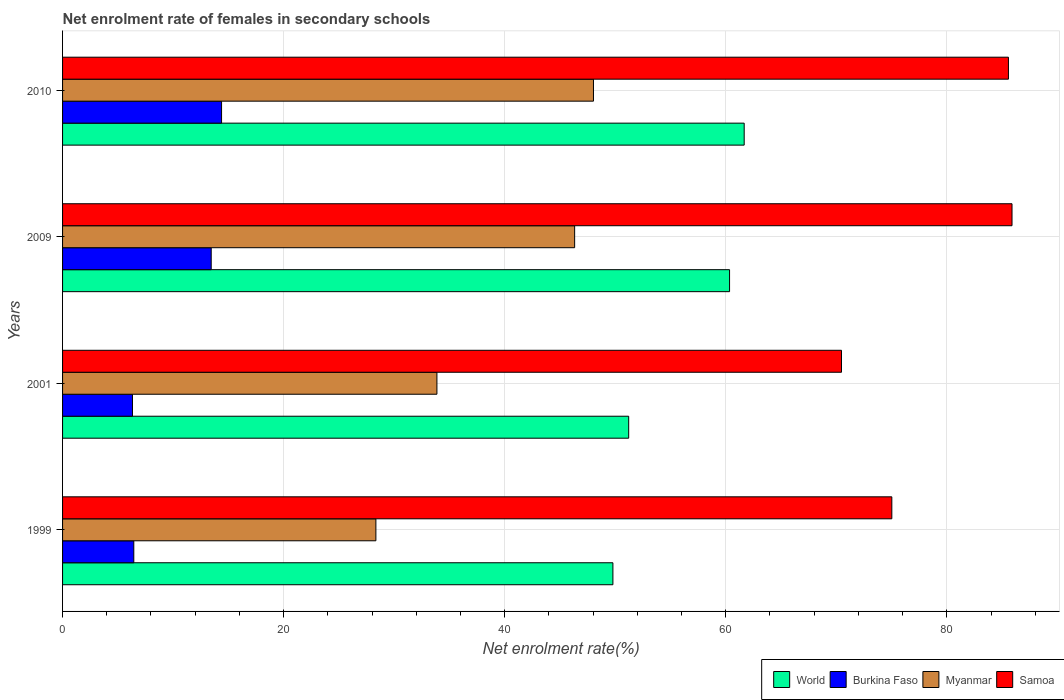Are the number of bars on each tick of the Y-axis equal?
Your response must be concise. Yes. How many bars are there on the 3rd tick from the top?
Your answer should be very brief. 4. How many bars are there on the 4th tick from the bottom?
Your answer should be compact. 4. What is the label of the 1st group of bars from the top?
Keep it short and to the point. 2010. What is the net enrolment rate of females in secondary schools in Myanmar in 2009?
Offer a terse response. 46.33. Across all years, what is the maximum net enrolment rate of females in secondary schools in World?
Give a very brief answer. 61.67. Across all years, what is the minimum net enrolment rate of females in secondary schools in Samoa?
Give a very brief answer. 70.47. In which year was the net enrolment rate of females in secondary schools in Samoa maximum?
Your response must be concise. 2009. What is the total net enrolment rate of females in secondary schools in Myanmar in the graph?
Provide a succinct answer. 156.58. What is the difference between the net enrolment rate of females in secondary schools in Burkina Faso in 2001 and that in 2009?
Provide a succinct answer. -7.12. What is the difference between the net enrolment rate of females in secondary schools in Burkina Faso in 2001 and the net enrolment rate of females in secondary schools in World in 1999?
Ensure brevity in your answer.  -43.47. What is the average net enrolment rate of females in secondary schools in Burkina Faso per year?
Provide a succinct answer. 10.15. In the year 2001, what is the difference between the net enrolment rate of females in secondary schools in World and net enrolment rate of females in secondary schools in Burkina Faso?
Keep it short and to the point. 44.89. In how many years, is the net enrolment rate of females in secondary schools in Myanmar greater than 24 %?
Provide a succinct answer. 4. What is the ratio of the net enrolment rate of females in secondary schools in Myanmar in 1999 to that in 2001?
Provide a short and direct response. 0.84. Is the net enrolment rate of females in secondary schools in Samoa in 1999 less than that in 2009?
Make the answer very short. Yes. What is the difference between the highest and the second highest net enrolment rate of females in secondary schools in World?
Offer a very short reply. 1.32. What is the difference between the highest and the lowest net enrolment rate of females in secondary schools in Burkina Faso?
Provide a short and direct response. 8.06. In how many years, is the net enrolment rate of females in secondary schools in Burkina Faso greater than the average net enrolment rate of females in secondary schools in Burkina Faso taken over all years?
Offer a terse response. 2. Is the sum of the net enrolment rate of females in secondary schools in Samoa in 2009 and 2010 greater than the maximum net enrolment rate of females in secondary schools in World across all years?
Offer a terse response. Yes. What does the 2nd bar from the top in 1999 represents?
Offer a very short reply. Myanmar. What does the 4th bar from the bottom in 2010 represents?
Provide a short and direct response. Samoa. How many years are there in the graph?
Offer a very short reply. 4. What is the difference between two consecutive major ticks on the X-axis?
Your answer should be compact. 20. Does the graph contain any zero values?
Ensure brevity in your answer.  No. Where does the legend appear in the graph?
Ensure brevity in your answer.  Bottom right. What is the title of the graph?
Your answer should be compact. Net enrolment rate of females in secondary schools. What is the label or title of the X-axis?
Make the answer very short. Net enrolment rate(%). What is the Net enrolment rate(%) in World in 1999?
Your response must be concise. 49.79. What is the Net enrolment rate(%) in Burkina Faso in 1999?
Ensure brevity in your answer.  6.44. What is the Net enrolment rate(%) of Myanmar in 1999?
Ensure brevity in your answer.  28.35. What is the Net enrolment rate(%) of Samoa in 1999?
Ensure brevity in your answer.  75.03. What is the Net enrolment rate(%) of World in 2001?
Make the answer very short. 51.22. What is the Net enrolment rate(%) of Burkina Faso in 2001?
Your answer should be compact. 6.33. What is the Net enrolment rate(%) of Myanmar in 2001?
Make the answer very short. 33.87. What is the Net enrolment rate(%) in Samoa in 2001?
Give a very brief answer. 70.47. What is the Net enrolment rate(%) in World in 2009?
Your response must be concise. 60.35. What is the Net enrolment rate(%) of Burkina Faso in 2009?
Give a very brief answer. 13.45. What is the Net enrolment rate(%) of Myanmar in 2009?
Your response must be concise. 46.33. What is the Net enrolment rate(%) in Samoa in 2009?
Offer a terse response. 85.9. What is the Net enrolment rate(%) of World in 2010?
Your response must be concise. 61.67. What is the Net enrolment rate(%) of Burkina Faso in 2010?
Your response must be concise. 14.39. What is the Net enrolment rate(%) of Myanmar in 2010?
Give a very brief answer. 48.03. What is the Net enrolment rate(%) of Samoa in 2010?
Ensure brevity in your answer.  85.58. Across all years, what is the maximum Net enrolment rate(%) in World?
Provide a short and direct response. 61.67. Across all years, what is the maximum Net enrolment rate(%) in Burkina Faso?
Your answer should be compact. 14.39. Across all years, what is the maximum Net enrolment rate(%) in Myanmar?
Offer a terse response. 48.03. Across all years, what is the maximum Net enrolment rate(%) in Samoa?
Make the answer very short. 85.9. Across all years, what is the minimum Net enrolment rate(%) of World?
Offer a very short reply. 49.79. Across all years, what is the minimum Net enrolment rate(%) in Burkina Faso?
Your answer should be very brief. 6.33. Across all years, what is the minimum Net enrolment rate(%) of Myanmar?
Offer a terse response. 28.35. Across all years, what is the minimum Net enrolment rate(%) in Samoa?
Offer a very short reply. 70.47. What is the total Net enrolment rate(%) of World in the graph?
Your answer should be very brief. 223.03. What is the total Net enrolment rate(%) of Burkina Faso in the graph?
Your response must be concise. 40.6. What is the total Net enrolment rate(%) in Myanmar in the graph?
Provide a succinct answer. 156.58. What is the total Net enrolment rate(%) of Samoa in the graph?
Give a very brief answer. 316.98. What is the difference between the Net enrolment rate(%) in World in 1999 and that in 2001?
Your response must be concise. -1.43. What is the difference between the Net enrolment rate(%) in Burkina Faso in 1999 and that in 2001?
Your answer should be compact. 0.12. What is the difference between the Net enrolment rate(%) in Myanmar in 1999 and that in 2001?
Provide a succinct answer. -5.52. What is the difference between the Net enrolment rate(%) in Samoa in 1999 and that in 2001?
Give a very brief answer. 4.55. What is the difference between the Net enrolment rate(%) of World in 1999 and that in 2009?
Your response must be concise. -10.55. What is the difference between the Net enrolment rate(%) in Burkina Faso in 1999 and that in 2009?
Offer a very short reply. -7. What is the difference between the Net enrolment rate(%) of Myanmar in 1999 and that in 2009?
Offer a terse response. -17.98. What is the difference between the Net enrolment rate(%) of Samoa in 1999 and that in 2009?
Offer a terse response. -10.88. What is the difference between the Net enrolment rate(%) of World in 1999 and that in 2010?
Keep it short and to the point. -11.88. What is the difference between the Net enrolment rate(%) of Burkina Faso in 1999 and that in 2010?
Keep it short and to the point. -7.94. What is the difference between the Net enrolment rate(%) of Myanmar in 1999 and that in 2010?
Keep it short and to the point. -19.69. What is the difference between the Net enrolment rate(%) of Samoa in 1999 and that in 2010?
Ensure brevity in your answer.  -10.55. What is the difference between the Net enrolment rate(%) of World in 2001 and that in 2009?
Your response must be concise. -9.13. What is the difference between the Net enrolment rate(%) of Burkina Faso in 2001 and that in 2009?
Your response must be concise. -7.12. What is the difference between the Net enrolment rate(%) in Myanmar in 2001 and that in 2009?
Your response must be concise. -12.46. What is the difference between the Net enrolment rate(%) in Samoa in 2001 and that in 2009?
Offer a terse response. -15.43. What is the difference between the Net enrolment rate(%) in World in 2001 and that in 2010?
Your response must be concise. -10.45. What is the difference between the Net enrolment rate(%) in Burkina Faso in 2001 and that in 2010?
Make the answer very short. -8.06. What is the difference between the Net enrolment rate(%) in Myanmar in 2001 and that in 2010?
Offer a very short reply. -14.16. What is the difference between the Net enrolment rate(%) in Samoa in 2001 and that in 2010?
Make the answer very short. -15.1. What is the difference between the Net enrolment rate(%) in World in 2009 and that in 2010?
Your answer should be compact. -1.32. What is the difference between the Net enrolment rate(%) of Burkina Faso in 2009 and that in 2010?
Offer a very short reply. -0.94. What is the difference between the Net enrolment rate(%) of Myanmar in 2009 and that in 2010?
Provide a succinct answer. -1.7. What is the difference between the Net enrolment rate(%) of Samoa in 2009 and that in 2010?
Provide a short and direct response. 0.32. What is the difference between the Net enrolment rate(%) in World in 1999 and the Net enrolment rate(%) in Burkina Faso in 2001?
Your answer should be very brief. 43.47. What is the difference between the Net enrolment rate(%) in World in 1999 and the Net enrolment rate(%) in Myanmar in 2001?
Ensure brevity in your answer.  15.92. What is the difference between the Net enrolment rate(%) in World in 1999 and the Net enrolment rate(%) in Samoa in 2001?
Keep it short and to the point. -20.68. What is the difference between the Net enrolment rate(%) in Burkina Faso in 1999 and the Net enrolment rate(%) in Myanmar in 2001?
Offer a very short reply. -27.43. What is the difference between the Net enrolment rate(%) in Burkina Faso in 1999 and the Net enrolment rate(%) in Samoa in 2001?
Give a very brief answer. -64.03. What is the difference between the Net enrolment rate(%) in Myanmar in 1999 and the Net enrolment rate(%) in Samoa in 2001?
Keep it short and to the point. -42.13. What is the difference between the Net enrolment rate(%) in World in 1999 and the Net enrolment rate(%) in Burkina Faso in 2009?
Provide a short and direct response. 36.34. What is the difference between the Net enrolment rate(%) in World in 1999 and the Net enrolment rate(%) in Myanmar in 2009?
Make the answer very short. 3.46. What is the difference between the Net enrolment rate(%) of World in 1999 and the Net enrolment rate(%) of Samoa in 2009?
Give a very brief answer. -36.11. What is the difference between the Net enrolment rate(%) in Burkina Faso in 1999 and the Net enrolment rate(%) in Myanmar in 2009?
Your response must be concise. -39.88. What is the difference between the Net enrolment rate(%) of Burkina Faso in 1999 and the Net enrolment rate(%) of Samoa in 2009?
Ensure brevity in your answer.  -79.46. What is the difference between the Net enrolment rate(%) in Myanmar in 1999 and the Net enrolment rate(%) in Samoa in 2009?
Your answer should be very brief. -57.55. What is the difference between the Net enrolment rate(%) of World in 1999 and the Net enrolment rate(%) of Burkina Faso in 2010?
Your answer should be compact. 35.41. What is the difference between the Net enrolment rate(%) of World in 1999 and the Net enrolment rate(%) of Myanmar in 2010?
Keep it short and to the point. 1.76. What is the difference between the Net enrolment rate(%) of World in 1999 and the Net enrolment rate(%) of Samoa in 2010?
Offer a very short reply. -35.79. What is the difference between the Net enrolment rate(%) in Burkina Faso in 1999 and the Net enrolment rate(%) in Myanmar in 2010?
Your answer should be very brief. -41.59. What is the difference between the Net enrolment rate(%) of Burkina Faso in 1999 and the Net enrolment rate(%) of Samoa in 2010?
Keep it short and to the point. -79.13. What is the difference between the Net enrolment rate(%) of Myanmar in 1999 and the Net enrolment rate(%) of Samoa in 2010?
Keep it short and to the point. -57.23. What is the difference between the Net enrolment rate(%) in World in 2001 and the Net enrolment rate(%) in Burkina Faso in 2009?
Your answer should be very brief. 37.77. What is the difference between the Net enrolment rate(%) of World in 2001 and the Net enrolment rate(%) of Myanmar in 2009?
Offer a terse response. 4.89. What is the difference between the Net enrolment rate(%) in World in 2001 and the Net enrolment rate(%) in Samoa in 2009?
Your answer should be very brief. -34.68. What is the difference between the Net enrolment rate(%) of Burkina Faso in 2001 and the Net enrolment rate(%) of Myanmar in 2009?
Your response must be concise. -40. What is the difference between the Net enrolment rate(%) of Burkina Faso in 2001 and the Net enrolment rate(%) of Samoa in 2009?
Offer a terse response. -79.58. What is the difference between the Net enrolment rate(%) of Myanmar in 2001 and the Net enrolment rate(%) of Samoa in 2009?
Make the answer very short. -52.03. What is the difference between the Net enrolment rate(%) in World in 2001 and the Net enrolment rate(%) in Burkina Faso in 2010?
Offer a terse response. 36.84. What is the difference between the Net enrolment rate(%) of World in 2001 and the Net enrolment rate(%) of Myanmar in 2010?
Provide a short and direct response. 3.19. What is the difference between the Net enrolment rate(%) of World in 2001 and the Net enrolment rate(%) of Samoa in 2010?
Your answer should be compact. -34.36. What is the difference between the Net enrolment rate(%) in Burkina Faso in 2001 and the Net enrolment rate(%) in Myanmar in 2010?
Keep it short and to the point. -41.71. What is the difference between the Net enrolment rate(%) in Burkina Faso in 2001 and the Net enrolment rate(%) in Samoa in 2010?
Give a very brief answer. -79.25. What is the difference between the Net enrolment rate(%) of Myanmar in 2001 and the Net enrolment rate(%) of Samoa in 2010?
Offer a very short reply. -51.71. What is the difference between the Net enrolment rate(%) of World in 2009 and the Net enrolment rate(%) of Burkina Faso in 2010?
Make the answer very short. 45.96. What is the difference between the Net enrolment rate(%) in World in 2009 and the Net enrolment rate(%) in Myanmar in 2010?
Keep it short and to the point. 12.31. What is the difference between the Net enrolment rate(%) of World in 2009 and the Net enrolment rate(%) of Samoa in 2010?
Provide a short and direct response. -25.23. What is the difference between the Net enrolment rate(%) in Burkina Faso in 2009 and the Net enrolment rate(%) in Myanmar in 2010?
Offer a very short reply. -34.59. What is the difference between the Net enrolment rate(%) of Burkina Faso in 2009 and the Net enrolment rate(%) of Samoa in 2010?
Keep it short and to the point. -72.13. What is the difference between the Net enrolment rate(%) in Myanmar in 2009 and the Net enrolment rate(%) in Samoa in 2010?
Give a very brief answer. -39.25. What is the average Net enrolment rate(%) in World per year?
Give a very brief answer. 55.76. What is the average Net enrolment rate(%) in Burkina Faso per year?
Keep it short and to the point. 10.15. What is the average Net enrolment rate(%) in Myanmar per year?
Provide a succinct answer. 39.15. What is the average Net enrolment rate(%) of Samoa per year?
Your response must be concise. 79.25. In the year 1999, what is the difference between the Net enrolment rate(%) in World and Net enrolment rate(%) in Burkina Faso?
Offer a terse response. 43.35. In the year 1999, what is the difference between the Net enrolment rate(%) of World and Net enrolment rate(%) of Myanmar?
Offer a terse response. 21.44. In the year 1999, what is the difference between the Net enrolment rate(%) of World and Net enrolment rate(%) of Samoa?
Provide a succinct answer. -25.23. In the year 1999, what is the difference between the Net enrolment rate(%) of Burkina Faso and Net enrolment rate(%) of Myanmar?
Make the answer very short. -21.9. In the year 1999, what is the difference between the Net enrolment rate(%) of Burkina Faso and Net enrolment rate(%) of Samoa?
Ensure brevity in your answer.  -68.58. In the year 1999, what is the difference between the Net enrolment rate(%) in Myanmar and Net enrolment rate(%) in Samoa?
Keep it short and to the point. -46.68. In the year 2001, what is the difference between the Net enrolment rate(%) in World and Net enrolment rate(%) in Burkina Faso?
Your answer should be very brief. 44.89. In the year 2001, what is the difference between the Net enrolment rate(%) of World and Net enrolment rate(%) of Myanmar?
Your answer should be very brief. 17.35. In the year 2001, what is the difference between the Net enrolment rate(%) in World and Net enrolment rate(%) in Samoa?
Give a very brief answer. -19.25. In the year 2001, what is the difference between the Net enrolment rate(%) in Burkina Faso and Net enrolment rate(%) in Myanmar?
Offer a very short reply. -27.54. In the year 2001, what is the difference between the Net enrolment rate(%) in Burkina Faso and Net enrolment rate(%) in Samoa?
Keep it short and to the point. -64.15. In the year 2001, what is the difference between the Net enrolment rate(%) of Myanmar and Net enrolment rate(%) of Samoa?
Your response must be concise. -36.6. In the year 2009, what is the difference between the Net enrolment rate(%) of World and Net enrolment rate(%) of Burkina Faso?
Offer a terse response. 46.9. In the year 2009, what is the difference between the Net enrolment rate(%) of World and Net enrolment rate(%) of Myanmar?
Your response must be concise. 14.02. In the year 2009, what is the difference between the Net enrolment rate(%) of World and Net enrolment rate(%) of Samoa?
Provide a succinct answer. -25.55. In the year 2009, what is the difference between the Net enrolment rate(%) of Burkina Faso and Net enrolment rate(%) of Myanmar?
Keep it short and to the point. -32.88. In the year 2009, what is the difference between the Net enrolment rate(%) of Burkina Faso and Net enrolment rate(%) of Samoa?
Give a very brief answer. -72.45. In the year 2009, what is the difference between the Net enrolment rate(%) in Myanmar and Net enrolment rate(%) in Samoa?
Offer a very short reply. -39.57. In the year 2010, what is the difference between the Net enrolment rate(%) in World and Net enrolment rate(%) in Burkina Faso?
Offer a terse response. 47.28. In the year 2010, what is the difference between the Net enrolment rate(%) in World and Net enrolment rate(%) in Myanmar?
Provide a short and direct response. 13.64. In the year 2010, what is the difference between the Net enrolment rate(%) of World and Net enrolment rate(%) of Samoa?
Ensure brevity in your answer.  -23.91. In the year 2010, what is the difference between the Net enrolment rate(%) in Burkina Faso and Net enrolment rate(%) in Myanmar?
Keep it short and to the point. -33.65. In the year 2010, what is the difference between the Net enrolment rate(%) of Burkina Faso and Net enrolment rate(%) of Samoa?
Make the answer very short. -71.19. In the year 2010, what is the difference between the Net enrolment rate(%) in Myanmar and Net enrolment rate(%) in Samoa?
Keep it short and to the point. -37.54. What is the ratio of the Net enrolment rate(%) of World in 1999 to that in 2001?
Provide a succinct answer. 0.97. What is the ratio of the Net enrolment rate(%) in Burkina Faso in 1999 to that in 2001?
Provide a succinct answer. 1.02. What is the ratio of the Net enrolment rate(%) of Myanmar in 1999 to that in 2001?
Your answer should be compact. 0.84. What is the ratio of the Net enrolment rate(%) in Samoa in 1999 to that in 2001?
Give a very brief answer. 1.06. What is the ratio of the Net enrolment rate(%) in World in 1999 to that in 2009?
Make the answer very short. 0.83. What is the ratio of the Net enrolment rate(%) in Burkina Faso in 1999 to that in 2009?
Your answer should be very brief. 0.48. What is the ratio of the Net enrolment rate(%) of Myanmar in 1999 to that in 2009?
Make the answer very short. 0.61. What is the ratio of the Net enrolment rate(%) of Samoa in 1999 to that in 2009?
Give a very brief answer. 0.87. What is the ratio of the Net enrolment rate(%) in World in 1999 to that in 2010?
Ensure brevity in your answer.  0.81. What is the ratio of the Net enrolment rate(%) of Burkina Faso in 1999 to that in 2010?
Provide a short and direct response. 0.45. What is the ratio of the Net enrolment rate(%) of Myanmar in 1999 to that in 2010?
Ensure brevity in your answer.  0.59. What is the ratio of the Net enrolment rate(%) in Samoa in 1999 to that in 2010?
Offer a very short reply. 0.88. What is the ratio of the Net enrolment rate(%) in World in 2001 to that in 2009?
Offer a terse response. 0.85. What is the ratio of the Net enrolment rate(%) in Burkina Faso in 2001 to that in 2009?
Provide a short and direct response. 0.47. What is the ratio of the Net enrolment rate(%) in Myanmar in 2001 to that in 2009?
Ensure brevity in your answer.  0.73. What is the ratio of the Net enrolment rate(%) of Samoa in 2001 to that in 2009?
Keep it short and to the point. 0.82. What is the ratio of the Net enrolment rate(%) of World in 2001 to that in 2010?
Provide a succinct answer. 0.83. What is the ratio of the Net enrolment rate(%) in Burkina Faso in 2001 to that in 2010?
Ensure brevity in your answer.  0.44. What is the ratio of the Net enrolment rate(%) of Myanmar in 2001 to that in 2010?
Your answer should be very brief. 0.71. What is the ratio of the Net enrolment rate(%) of Samoa in 2001 to that in 2010?
Your answer should be compact. 0.82. What is the ratio of the Net enrolment rate(%) in World in 2009 to that in 2010?
Give a very brief answer. 0.98. What is the ratio of the Net enrolment rate(%) of Burkina Faso in 2009 to that in 2010?
Your response must be concise. 0.93. What is the ratio of the Net enrolment rate(%) of Myanmar in 2009 to that in 2010?
Give a very brief answer. 0.96. What is the ratio of the Net enrolment rate(%) of Samoa in 2009 to that in 2010?
Provide a succinct answer. 1. What is the difference between the highest and the second highest Net enrolment rate(%) of World?
Provide a short and direct response. 1.32. What is the difference between the highest and the second highest Net enrolment rate(%) of Burkina Faso?
Keep it short and to the point. 0.94. What is the difference between the highest and the second highest Net enrolment rate(%) in Myanmar?
Offer a terse response. 1.7. What is the difference between the highest and the second highest Net enrolment rate(%) in Samoa?
Provide a succinct answer. 0.32. What is the difference between the highest and the lowest Net enrolment rate(%) in World?
Make the answer very short. 11.88. What is the difference between the highest and the lowest Net enrolment rate(%) of Burkina Faso?
Give a very brief answer. 8.06. What is the difference between the highest and the lowest Net enrolment rate(%) of Myanmar?
Give a very brief answer. 19.69. What is the difference between the highest and the lowest Net enrolment rate(%) of Samoa?
Keep it short and to the point. 15.43. 